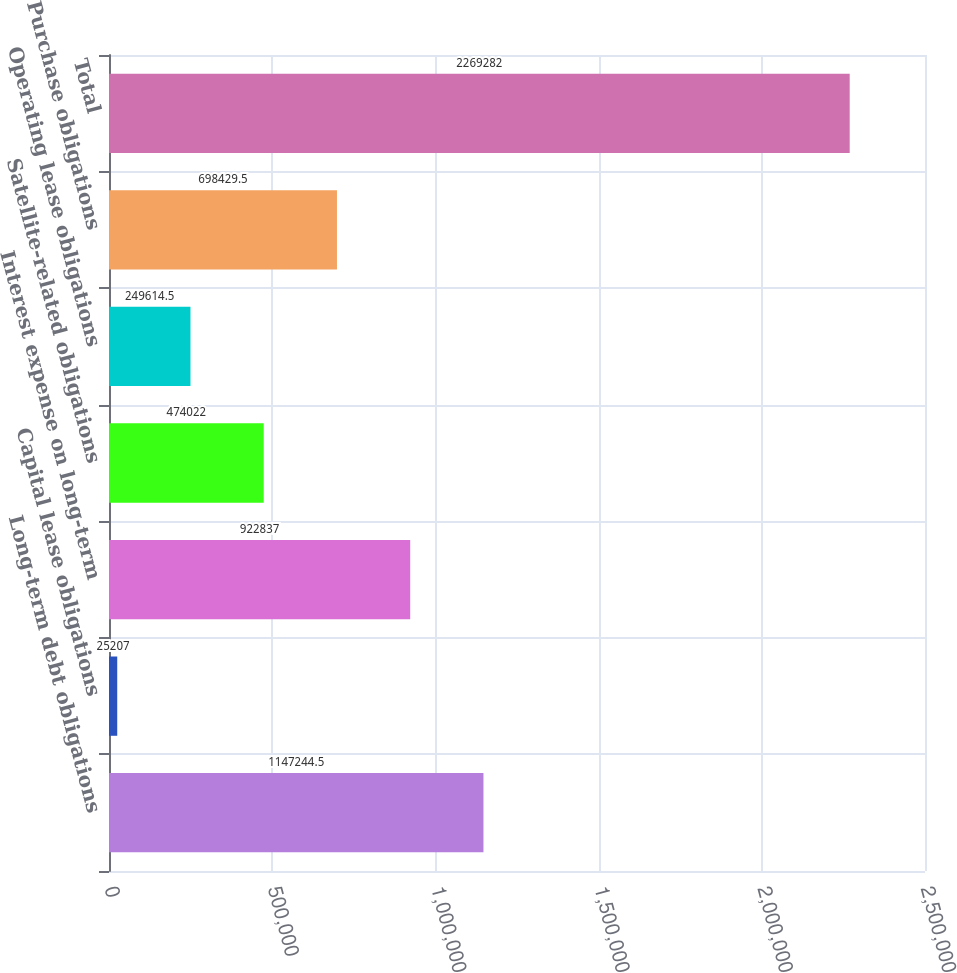Convert chart to OTSL. <chart><loc_0><loc_0><loc_500><loc_500><bar_chart><fcel>Long-term debt obligations<fcel>Capital lease obligations<fcel>Interest expense on long-term<fcel>Satellite-related obligations<fcel>Operating lease obligations<fcel>Purchase obligations<fcel>Total<nl><fcel>1.14724e+06<fcel>25207<fcel>922837<fcel>474022<fcel>249614<fcel>698430<fcel>2.26928e+06<nl></chart> 